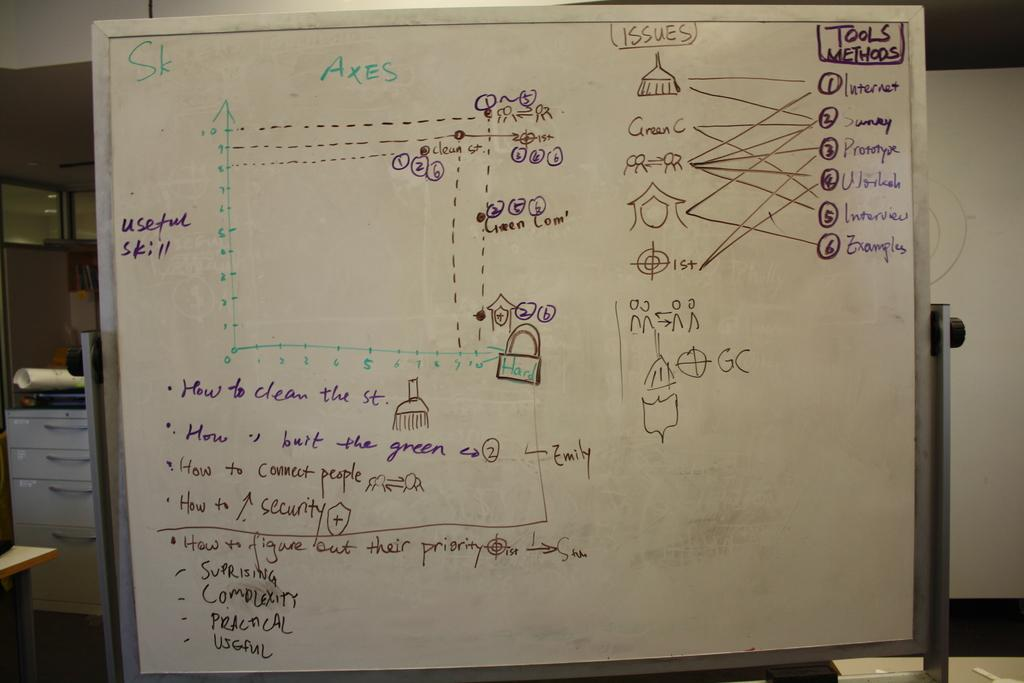<image>
Offer a succinct explanation of the picture presented. the letters GC are on the white board inside 